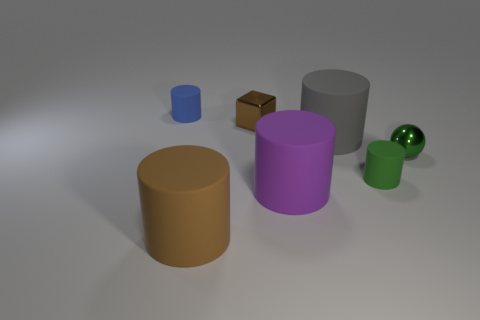Subtract 1 cylinders. How many cylinders are left? 4 Subtract all big purple cylinders. How many cylinders are left? 4 Subtract all blue cylinders. How many cylinders are left? 4 Subtract all red cylinders. Subtract all brown spheres. How many cylinders are left? 5 Add 2 big brown matte objects. How many objects exist? 9 Subtract all spheres. How many objects are left? 6 Subtract 0 yellow blocks. How many objects are left? 7 Subtract all big brown cylinders. Subtract all green cylinders. How many objects are left? 5 Add 2 small balls. How many small balls are left? 3 Add 1 brown shiny things. How many brown shiny things exist? 2 